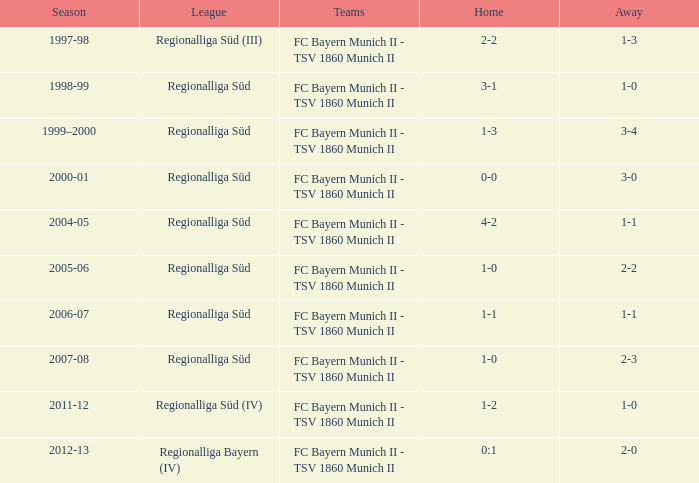Which squads were in the 2006-07 season? FC Bayern Munich II - TSV 1860 Munich II. 